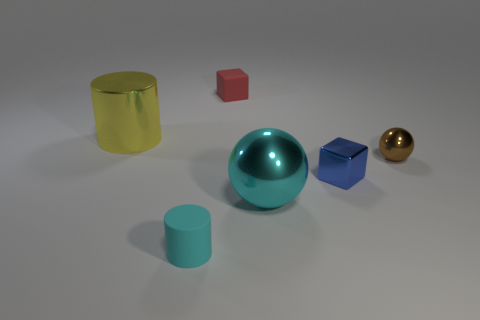Add 1 tiny cyan objects. How many objects exist? 7 Add 4 big shiny things. How many big shiny things exist? 6 Subtract all cyan spheres. How many spheres are left? 1 Subtract 0 green spheres. How many objects are left? 6 Subtract all cylinders. How many objects are left? 4 Subtract all green cylinders. Subtract all green spheres. How many cylinders are left? 2 Subtract all green cylinders. How many yellow spheres are left? 0 Subtract all big cylinders. Subtract all matte things. How many objects are left? 3 Add 5 metallic objects. How many metallic objects are left? 9 